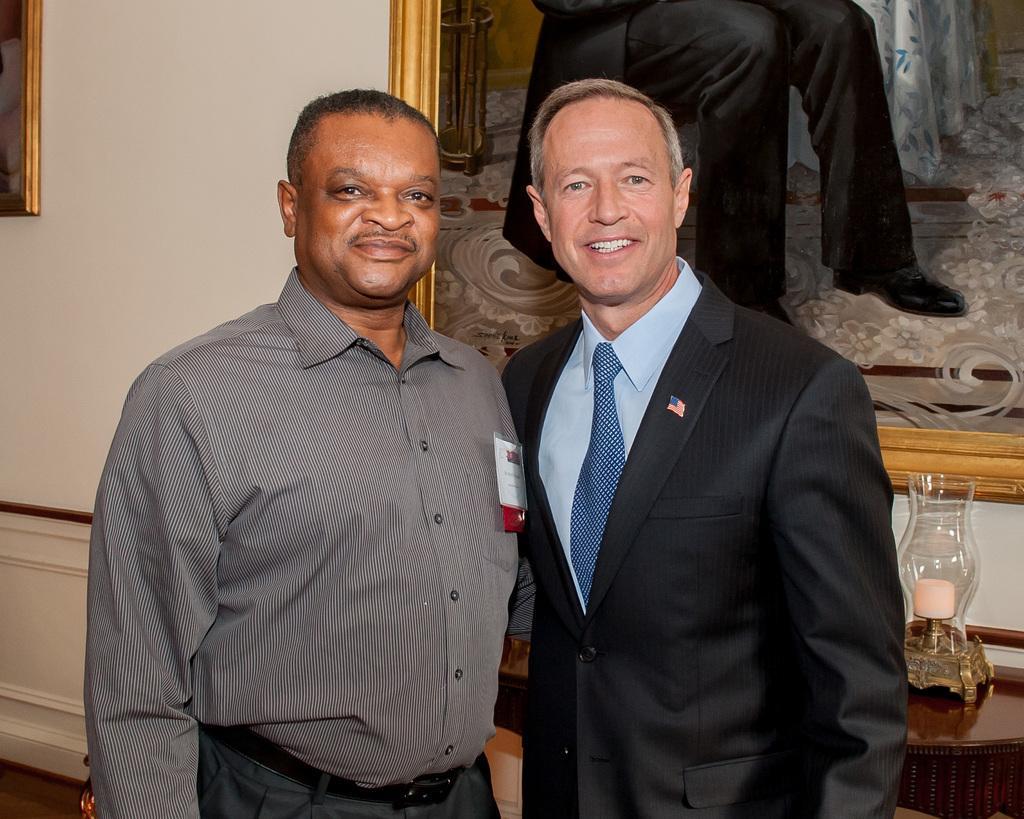Please provide a concise description of this image. In this image, we can see two persons wearing clothes. There is a photo frame on the wall. There is a lamp on the bottom right of the image. 